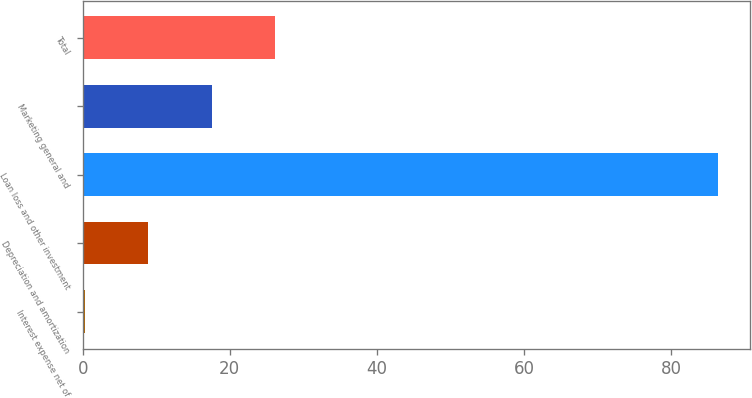Convert chart. <chart><loc_0><loc_0><loc_500><loc_500><bar_chart><fcel>Interest expense net of<fcel>Depreciation and amortization<fcel>Loan loss and other investment<fcel>Marketing general and<fcel>Total<nl><fcel>0.3<fcel>8.91<fcel>86.4<fcel>17.52<fcel>26.13<nl></chart> 